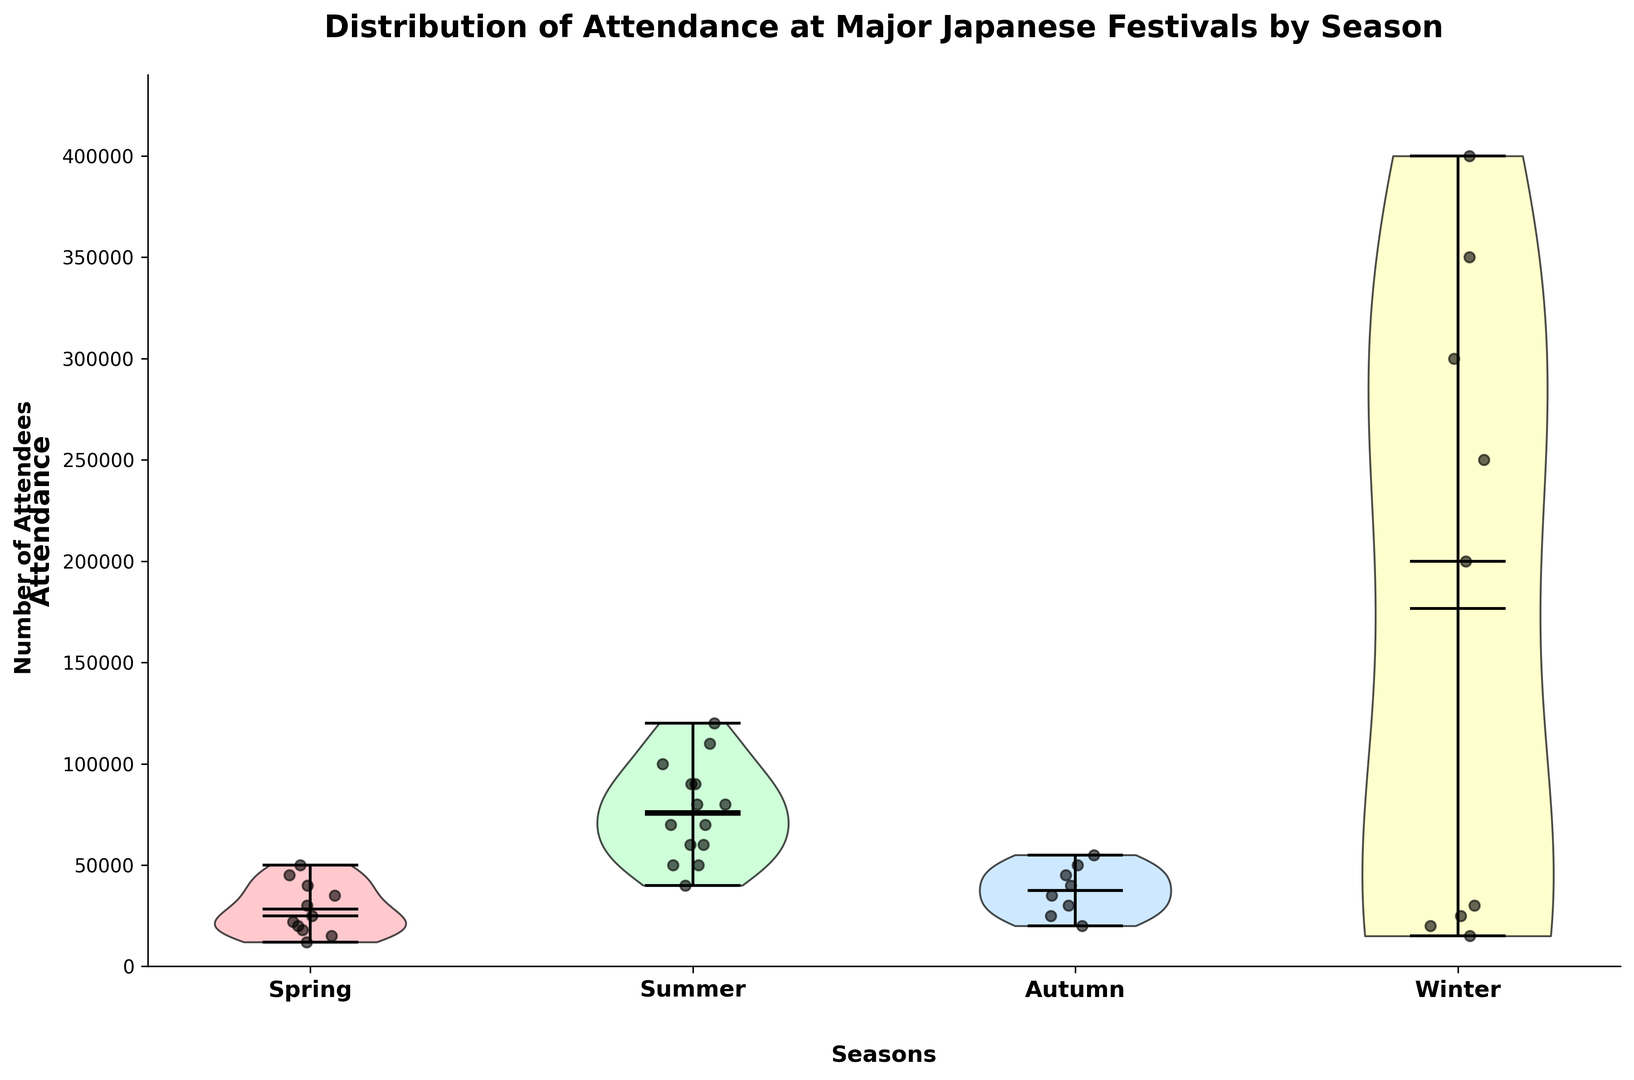Which season has the highest attendance overall? The winter season has the highest attendance as shown by the highest median and highest means in the violin plot.
Answer: Winter Which festival shows the widest range of attendance? The Sapporo Snow Festival in the winter shows the widest range, as it spans from 200,000 to 400,000 attendees.
Answer: Sapporo Snow Festival Which season has the lowest median attendance? The spring season has the lowest median attendance as indicated by the violin plot's median marker.
Answer: Spring How does the average attendance of summer festivals compare to that of autumn festivals? By observing the mean markers in the violin plots, the average attendance for summer (around 85,000) is higher than that for autumn (around 37,500).
Answer: Summer festivals have higher average attendance In which season is the difference between the minimum and maximum attendance the smallest? Taking a look at the range markers in the violin plots, the autumn season has the smallest difference between the minimum and maximum attendance, from 20,000 to 55,000.
Answer: Autumn Which festival has the highest attendance in the summer? Observing the scatter points and summary statistics within the violin plot, Obon has the highest attendance in summer, reaching up to 120,000 attendees.
Answer: Obon What is the most common range of attendance for spring festivals? The density of the violin plots for spring shows that the most common range for attendance is between 12,000 and 45,000.
Answer: 12,000 to 45,000 Is the attendance at the Chichibu Night Festival larger or smaller than at Hanami? Observing the scatter points and overall distribution, the Chichibu Night Festival (winter) has slightly larger attendance than Hanami (spring) with its range from 15,000 to 30,000, compared to Hanami's 12,000 to 25,000.
Answer: Larger Which season shows bimodal attendance distributions, if any? Checking the shape of the violin plots, the summer season shows some signs of bimodality, with peaks around 70,000 and 110,000.
Answer: Summer How much higher is the maximum attendance in winter compared to spring? The maximum attendance in winter is 400,000 (Sapporo Snow Festival), while in spring it is 50,000 (Sanja Matsuri), making the winter's maximum 350,000 higher.
Answer: 350,000 